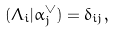<formula> <loc_0><loc_0><loc_500><loc_500>( \Lambda _ { i } | \alpha _ { j } ^ { \vee } ) = \delta _ { i j } ,</formula> 